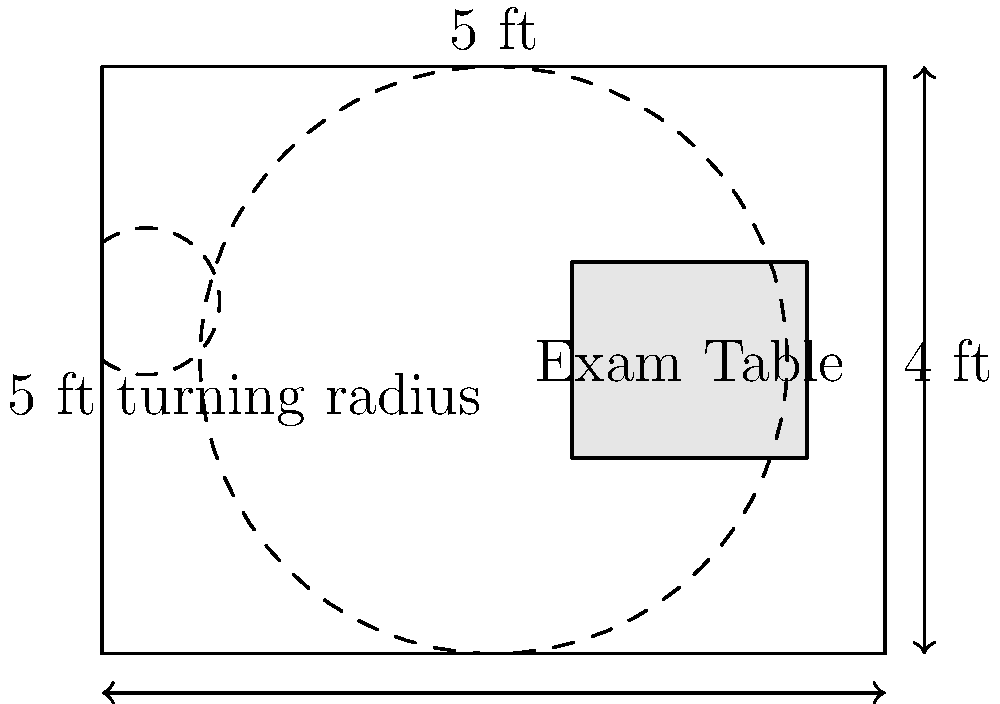Based on the blueprint of an accessible exam room shown above, what is the minimum width of the doorway to ensure wheelchair accessibility? To determine the minimum width of the doorway for wheelchair accessibility, we need to consider standard accessibility guidelines. Let's break it down:

1. The Americans with Disabilities Act (ADA) provides guidelines for accessible design in healthcare settings.

2. According to ADA standards, the minimum clear width for a doorway is 32 inches (81.28 cm) when measured from the face of the door to the opposite stop.

3. This 32-inch clearance ensures that most wheelchairs can pass through comfortably.

4. In the blueprint, we can see that the door is represented by a gap in the left wall of the room.

5. While the exact measurement isn't provided in the diagram, we can infer that it must meet or exceed this 32-inch minimum to be considered accessible.

6. It's worth noting that many healthcare facilities opt for wider doorways (36 inches or more) to provide even easier access and accommodate larger mobility devices.

7. The 5-foot (60-inch) turning radius shown in the room also indicates that the room is designed with wheelchair maneuverability in mind, which further supports the assumption that the doorway meets accessibility standards.

Therefore, based on ADA guidelines and the context of the accessible exam room design, we can conclude that the minimum width of the doorway should be 32 inches.
Answer: 32 inches 